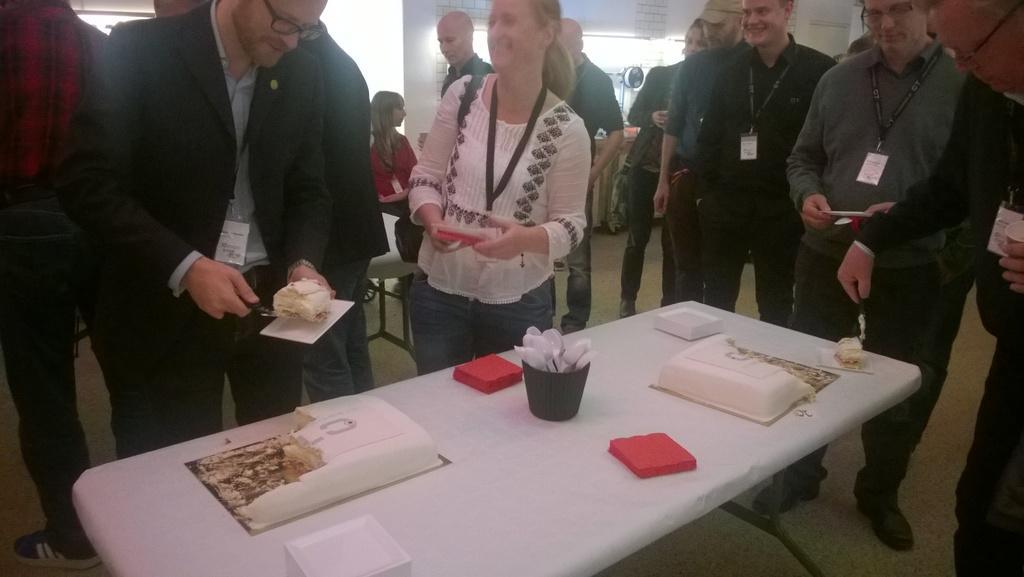Can you describe this image briefly? In the image few people are standing near to the table, On the table there is cake, spoons and plates. 